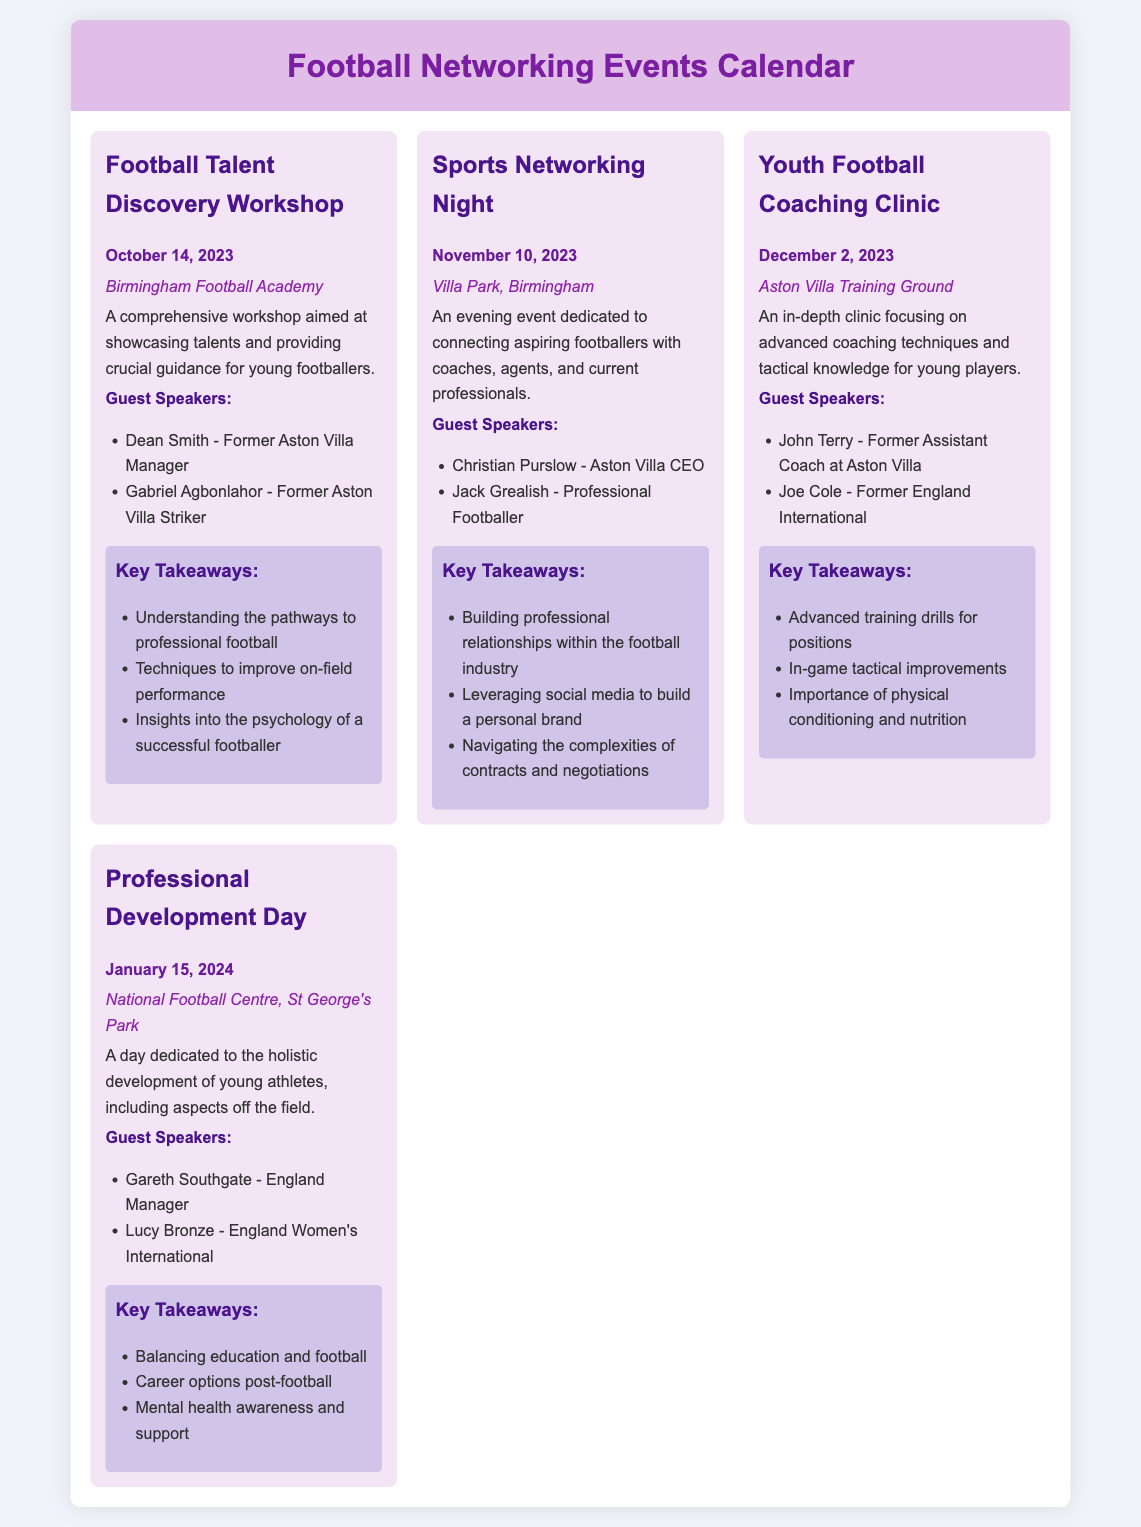What is the date of the Football Talent Discovery Workshop? The date is listed under the event, which states October 14, 2023.
Answer: October 14, 2023 Who is a guest speaker for the Sports Networking Night? The document includes a list of guest speakers, one of which is Christian Purslow.
Answer: Christian Purslow What is the location of the Youth Football Coaching Clinic? The location is provided in the event description, stating it will take place at the Aston Villa Training Ground.
Answer: Aston Villa Training Ground What are two key takeaways from the Professional Development Day? The takeaways are listed under the event, including balancing education and football and mental health awareness and support.
Answer: Balancing education and football, mental health awareness and support How many guest speakers are listed for the Football Talent Discovery Workshop? The document specifies that there are two guest speakers for this event.
Answer: Two What type of event is scheduled for November 10, 2023? The type is indicated in the title of the event, which is Sports Networking Night.
Answer: Sports Networking Night Who is one of the guest speakers for the Youth Football Coaching Clinic? The document provides a list of speakers, one of whom is John Terry.
Answer: John Terry What is a key takeaway from the Sports Networking Night? The takeaways are stated in a list, one of which is building professional relationships within the football industry.
Answer: Building professional relationships within the football industry 